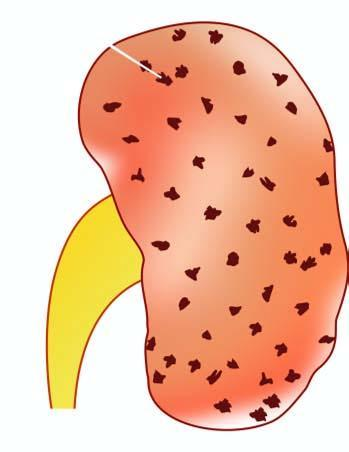what does the cortex show?
Answer the question using a single word or phrase. Characteristic 'flea bitten kidney ' 